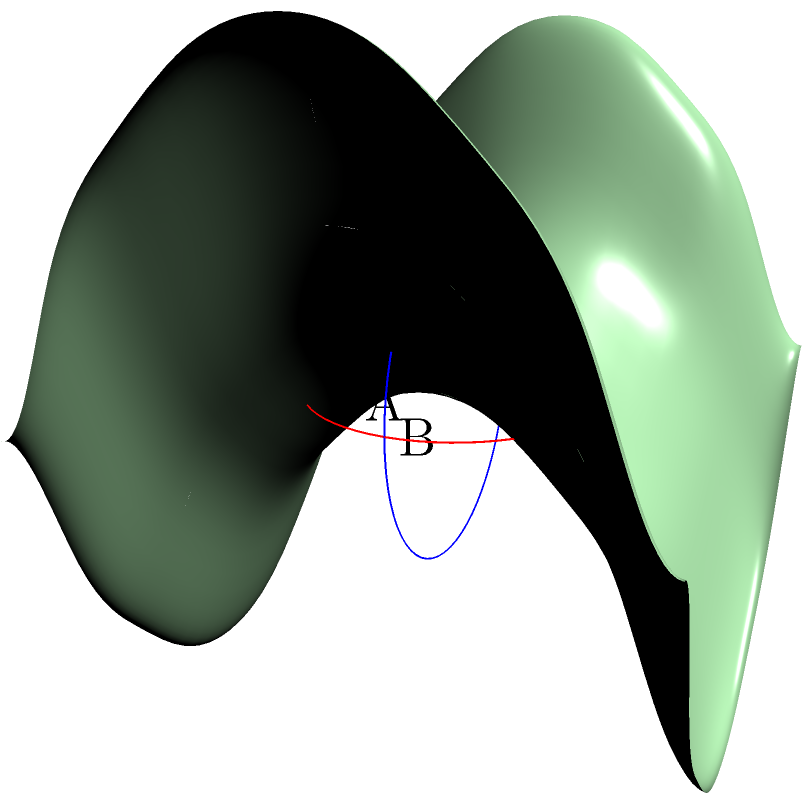In the context of furniture arrangement on a saddle-shaped surface, consider two circles A and B represented on the surface as shown in the diagram. Circle A lies in a plane parallel to the XY-plane, while circle B lies in a plane parallel to the YZ-plane. If both circles have the same radius $r$ in Euclidean space, how does their appearance on the saddle surface differ, and what implications does this have for balanced furniture placement? To understand the appearance of circles A and B on the saddle surface and its implications for furniture placement, let's analyze the problem step-by-step:

1. Surface geometry:
   The saddle surface is described by the equation $z = \frac{1}{2}(x^2 - y^2)$, which creates a hyperbolic paraboloid shape.

2. Circle A (parallel to XY-plane):
   - As it lies parallel to the XY-plane, its projection onto the saddle surface will be distorted.
   - Points along the X-axis will appear to curve upward, while points along the Y-axis will curve downward.
   - The circle will appear elongated in the X-direction and compressed in the Y-direction.

3. Circle B (parallel to YZ-plane):
   - This circle is perpendicular to the XY-plane and will intersect the saddle surface.
   - The top and bottom points of the circle will lie on the surface, while the middle sections will appear to curve inward.
   - The circle will look like an oval that's pinched in the middle.

4. Comparison of distortions:
   - Circle A will appear larger overall due to its orientation parallel to the surface's curvature.
   - Circle B will appear smaller and more dramatically distorted due to its perpendicular orientation to the surface's primary curvature.

5. Implications for furniture placement:
   - Circular furniture placed like Circle A will appear larger and more spread out, potentially dominating the space.
   - Furniture arranged like Circle B will seem more compact but may create a sense of instability due to the curvature.
   - To achieve balance, designers should consider mixing both orientations and adjusting sizes to compensate for the visual distortions.

6. Utilizing natural light:
   - The varying curvatures will affect how light interacts with objects on the surface.
   - Furniture placed like Circle A may cast longer shadows in the X-direction.
   - Furniture placed like Circle B may create interesting light and shadow patterns due to the surface's curvature.

By understanding these geometric properties, designers can create a balanced arrangement that works with the unique properties of the saddle-shaped surface, utilizing the distortions to create visual interest while maintaining functional space.
Answer: Circle A appears elongated in X-direction and compressed in Y-direction, while Circle B looks like a pinched oval. This requires mixing orientations and adjusting furniture sizes for balanced placement, considering distortions and light interactions. 